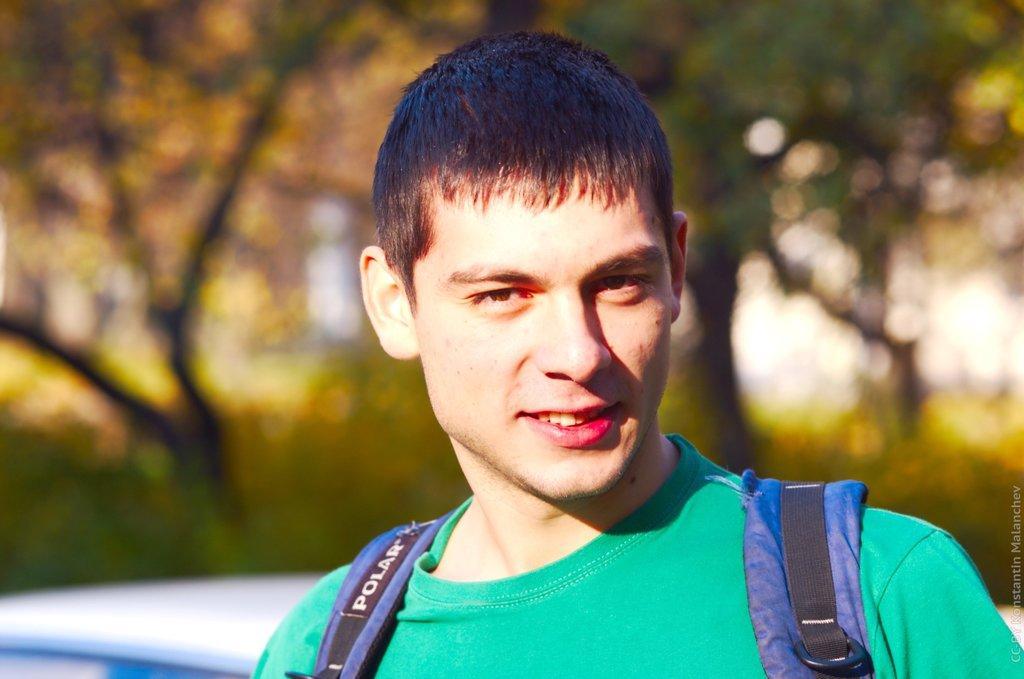Could you give a brief overview of what you see in this image? In this picture I can observe a man in the middle of the picture. He is wearing green color T shirt. The background is blurred. 